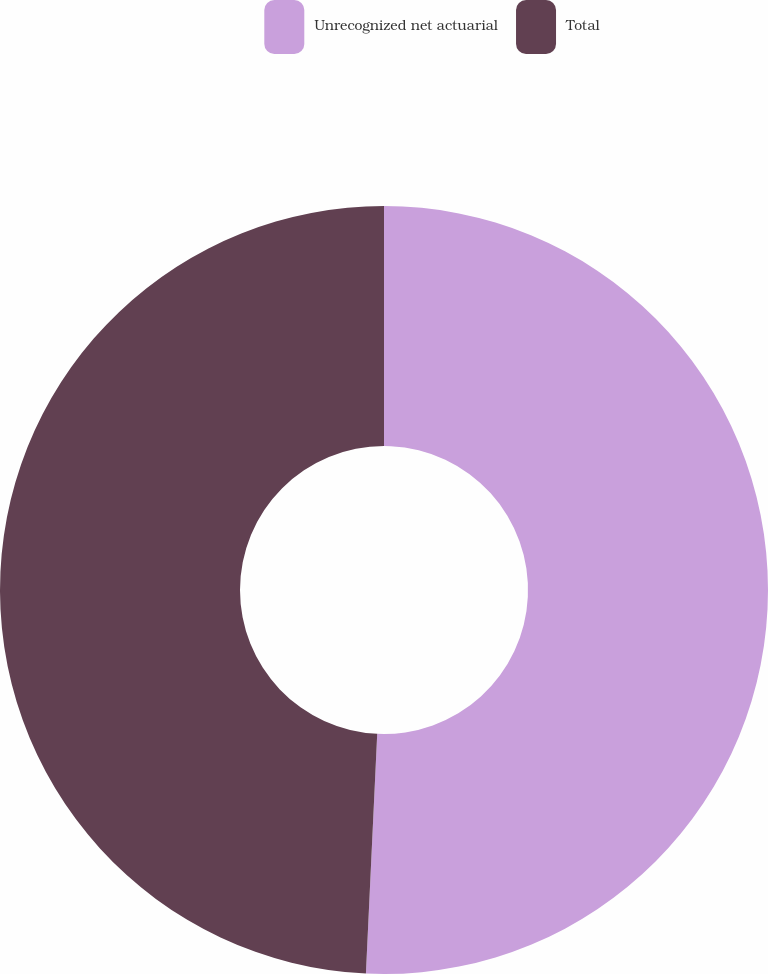Convert chart. <chart><loc_0><loc_0><loc_500><loc_500><pie_chart><fcel>Unrecognized net actuarial<fcel>Total<nl><fcel>50.75%<fcel>49.25%<nl></chart> 